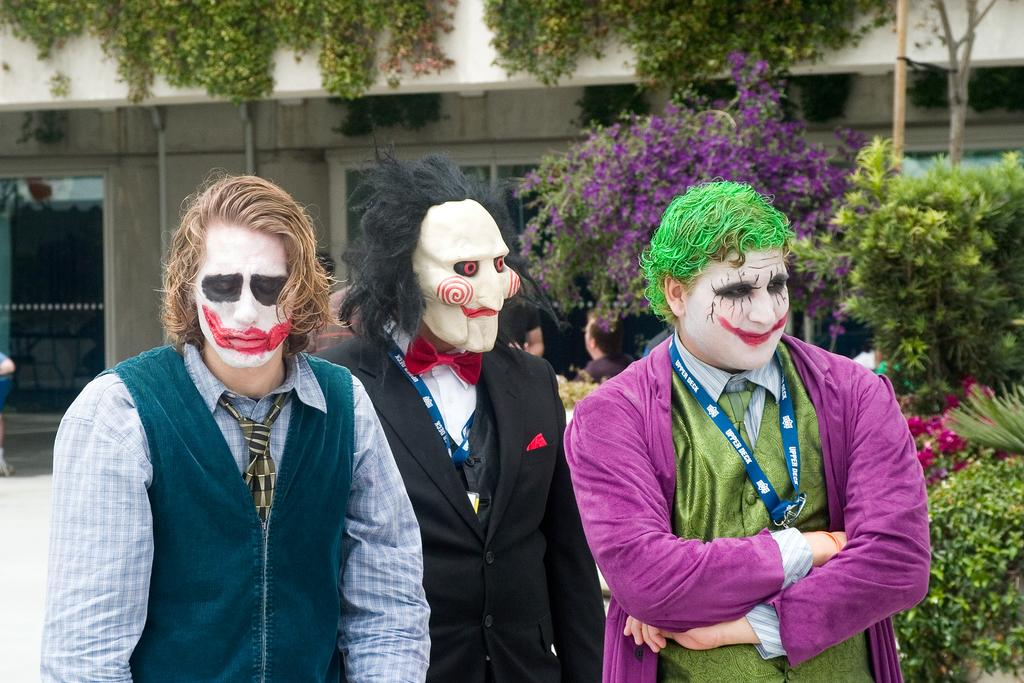How many people are standing in the image? There are 3 people standing in the image. What is unique about the person at the center? The person at the center is wearing a mask. What is the theme of the face paint on the other two people? The other two people have their faces painted as jokers. What can be seen in the background of the image? There are plants, other people, and buildings visible in the background of the image. What is the connection between the rate of inflation and the glove in the image? There is no glove present in the image, and the rate of inflation is not mentioned or depicted in any way. 